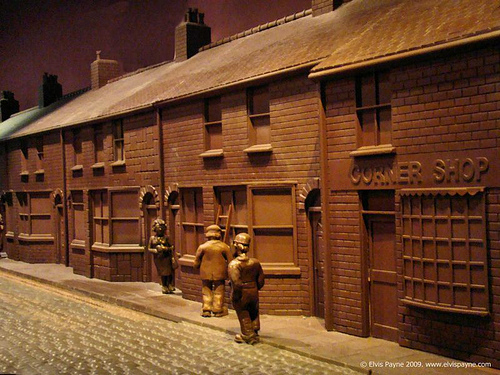<image>
Can you confirm if the man is behind the woman? No. The man is not behind the woman. From this viewpoint, the man appears to be positioned elsewhere in the scene. 